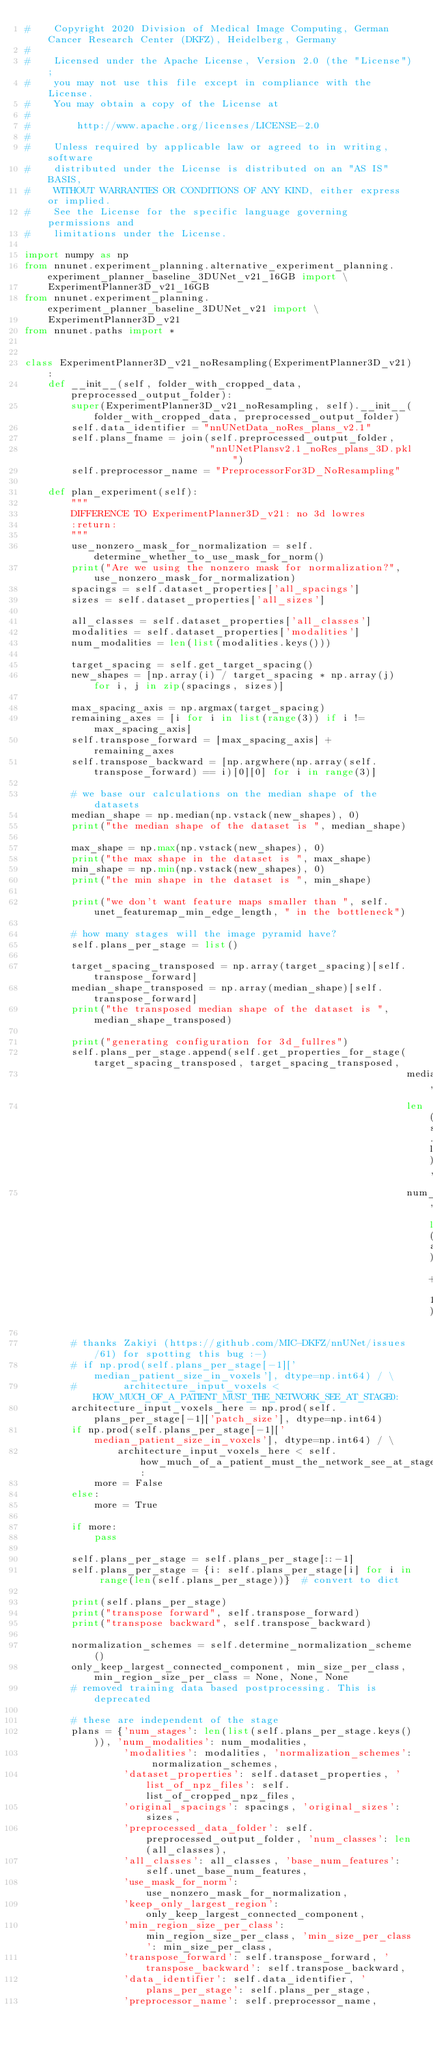Convert code to text. <code><loc_0><loc_0><loc_500><loc_500><_Python_>#    Copyright 2020 Division of Medical Image Computing, German Cancer Research Center (DKFZ), Heidelberg, Germany
#
#    Licensed under the Apache License, Version 2.0 (the "License");
#    you may not use this file except in compliance with the License.
#    You may obtain a copy of the License at
#
#        http://www.apache.org/licenses/LICENSE-2.0
#
#    Unless required by applicable law or agreed to in writing, software
#    distributed under the License is distributed on an "AS IS" BASIS,
#    WITHOUT WARRANTIES OR CONDITIONS OF ANY KIND, either express or implied.
#    See the License for the specific language governing permissions and
#    limitations under the License.

import numpy as np
from nnunet.experiment_planning.alternative_experiment_planning.experiment_planner_baseline_3DUNet_v21_16GB import \
    ExperimentPlanner3D_v21_16GB
from nnunet.experiment_planning.experiment_planner_baseline_3DUNet_v21 import \
    ExperimentPlanner3D_v21
from nnunet.paths import *


class ExperimentPlanner3D_v21_noResampling(ExperimentPlanner3D_v21):
    def __init__(self, folder_with_cropped_data, preprocessed_output_folder):
        super(ExperimentPlanner3D_v21_noResampling, self).__init__(folder_with_cropped_data, preprocessed_output_folder)
        self.data_identifier = "nnUNetData_noRes_plans_v2.1"
        self.plans_fname = join(self.preprocessed_output_folder,
                                "nnUNetPlansv2.1_noRes_plans_3D.pkl")
        self.preprocessor_name = "PreprocessorFor3D_NoResampling"

    def plan_experiment(self):
        """
        DIFFERENCE TO ExperimentPlanner3D_v21: no 3d lowres
        :return:
        """
        use_nonzero_mask_for_normalization = self.determine_whether_to_use_mask_for_norm()
        print("Are we using the nonzero mask for normalization?", use_nonzero_mask_for_normalization)
        spacings = self.dataset_properties['all_spacings']
        sizes = self.dataset_properties['all_sizes']

        all_classes = self.dataset_properties['all_classes']
        modalities = self.dataset_properties['modalities']
        num_modalities = len(list(modalities.keys()))

        target_spacing = self.get_target_spacing()
        new_shapes = [np.array(i) / target_spacing * np.array(j) for i, j in zip(spacings, sizes)]

        max_spacing_axis = np.argmax(target_spacing)
        remaining_axes = [i for i in list(range(3)) if i != max_spacing_axis]
        self.transpose_forward = [max_spacing_axis] + remaining_axes
        self.transpose_backward = [np.argwhere(np.array(self.transpose_forward) == i)[0][0] for i in range(3)]

        # we base our calculations on the median shape of the datasets
        median_shape = np.median(np.vstack(new_shapes), 0)
        print("the median shape of the dataset is ", median_shape)

        max_shape = np.max(np.vstack(new_shapes), 0)
        print("the max shape in the dataset is ", max_shape)
        min_shape = np.min(np.vstack(new_shapes), 0)
        print("the min shape in the dataset is ", min_shape)

        print("we don't want feature maps smaller than ", self.unet_featuremap_min_edge_length, " in the bottleneck")

        # how many stages will the image pyramid have?
        self.plans_per_stage = list()

        target_spacing_transposed = np.array(target_spacing)[self.transpose_forward]
        median_shape_transposed = np.array(median_shape)[self.transpose_forward]
        print("the transposed median shape of the dataset is ", median_shape_transposed)

        print("generating configuration for 3d_fullres")
        self.plans_per_stage.append(self.get_properties_for_stage(target_spacing_transposed, target_spacing_transposed,
                                                                  median_shape_transposed,
                                                                  len(self.list_of_cropped_npz_files),
                                                                  num_modalities, len(all_classes) + 1))

        # thanks Zakiyi (https://github.com/MIC-DKFZ/nnUNet/issues/61) for spotting this bug :-)
        # if np.prod(self.plans_per_stage[-1]['median_patient_size_in_voxels'], dtype=np.int64) / \
        #        architecture_input_voxels < HOW_MUCH_OF_A_PATIENT_MUST_THE_NETWORK_SEE_AT_STAGE0:
        architecture_input_voxels_here = np.prod(self.plans_per_stage[-1]['patch_size'], dtype=np.int64)
        if np.prod(self.plans_per_stage[-1]['median_patient_size_in_voxels'], dtype=np.int64) / \
                architecture_input_voxels_here < self.how_much_of_a_patient_must_the_network_see_at_stage0:
            more = False
        else:
            more = True

        if more:
            pass

        self.plans_per_stage = self.plans_per_stage[::-1]
        self.plans_per_stage = {i: self.plans_per_stage[i] for i in range(len(self.plans_per_stage))}  # convert to dict

        print(self.plans_per_stage)
        print("transpose forward", self.transpose_forward)
        print("transpose backward", self.transpose_backward)

        normalization_schemes = self.determine_normalization_scheme()
        only_keep_largest_connected_component, min_size_per_class, min_region_size_per_class = None, None, None
        # removed training data based postprocessing. This is deprecated

        # these are independent of the stage
        plans = {'num_stages': len(list(self.plans_per_stage.keys())), 'num_modalities': num_modalities,
                 'modalities': modalities, 'normalization_schemes': normalization_schemes,
                 'dataset_properties': self.dataset_properties, 'list_of_npz_files': self.list_of_cropped_npz_files,
                 'original_spacings': spacings, 'original_sizes': sizes,
                 'preprocessed_data_folder': self.preprocessed_output_folder, 'num_classes': len(all_classes),
                 'all_classes': all_classes, 'base_num_features': self.unet_base_num_features,
                 'use_mask_for_norm': use_nonzero_mask_for_normalization,
                 'keep_only_largest_region': only_keep_largest_connected_component,
                 'min_region_size_per_class': min_region_size_per_class, 'min_size_per_class': min_size_per_class,
                 'transpose_forward': self.transpose_forward, 'transpose_backward': self.transpose_backward,
                 'data_identifier': self.data_identifier, 'plans_per_stage': self.plans_per_stage,
                 'preprocessor_name': self.preprocessor_name,</code> 